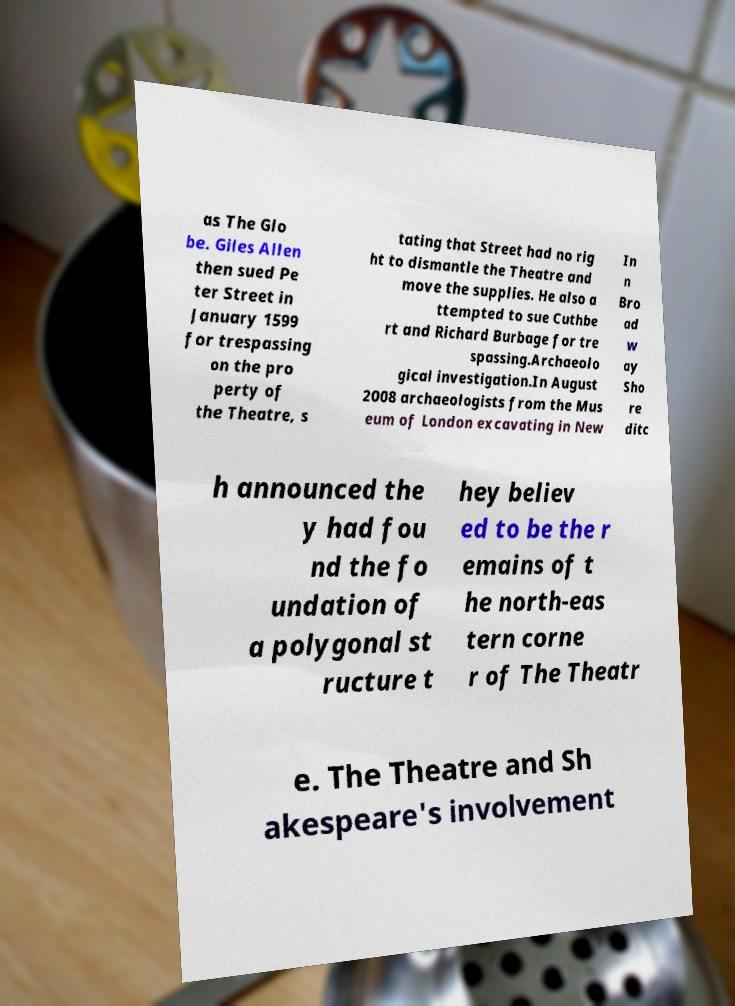What messages or text are displayed in this image? I need them in a readable, typed format. as The Glo be. Giles Allen then sued Pe ter Street in January 1599 for trespassing on the pro perty of the Theatre, s tating that Street had no rig ht to dismantle the Theatre and move the supplies. He also a ttempted to sue Cuthbe rt and Richard Burbage for tre spassing.Archaeolo gical investigation.In August 2008 archaeologists from the Mus eum of London excavating in New In n Bro ad w ay Sho re ditc h announced the y had fou nd the fo undation of a polygonal st ructure t hey believ ed to be the r emains of t he north-eas tern corne r of The Theatr e. The Theatre and Sh akespeare's involvement 